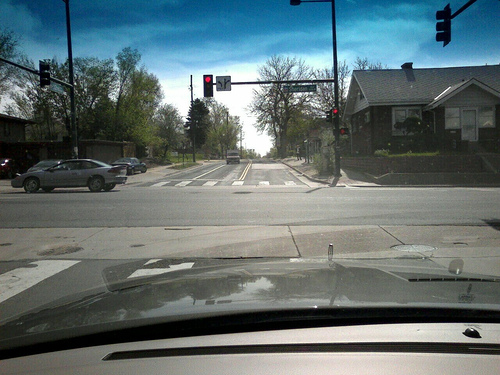How many cars are in the photo? 2 